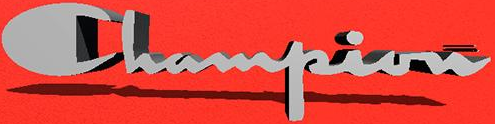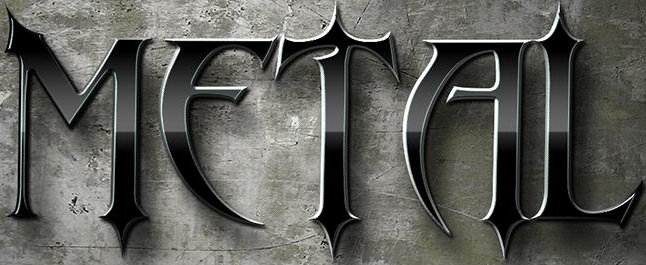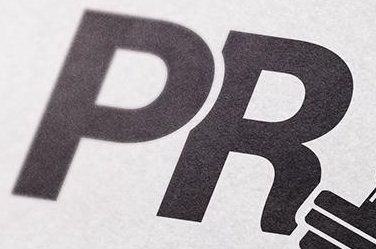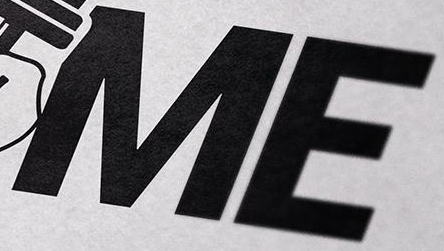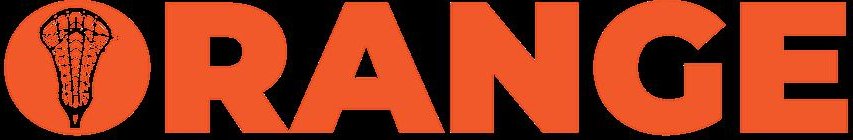Read the text content from these images in order, separated by a semicolon. Champion; METAL; PR; ME; ORANGE 